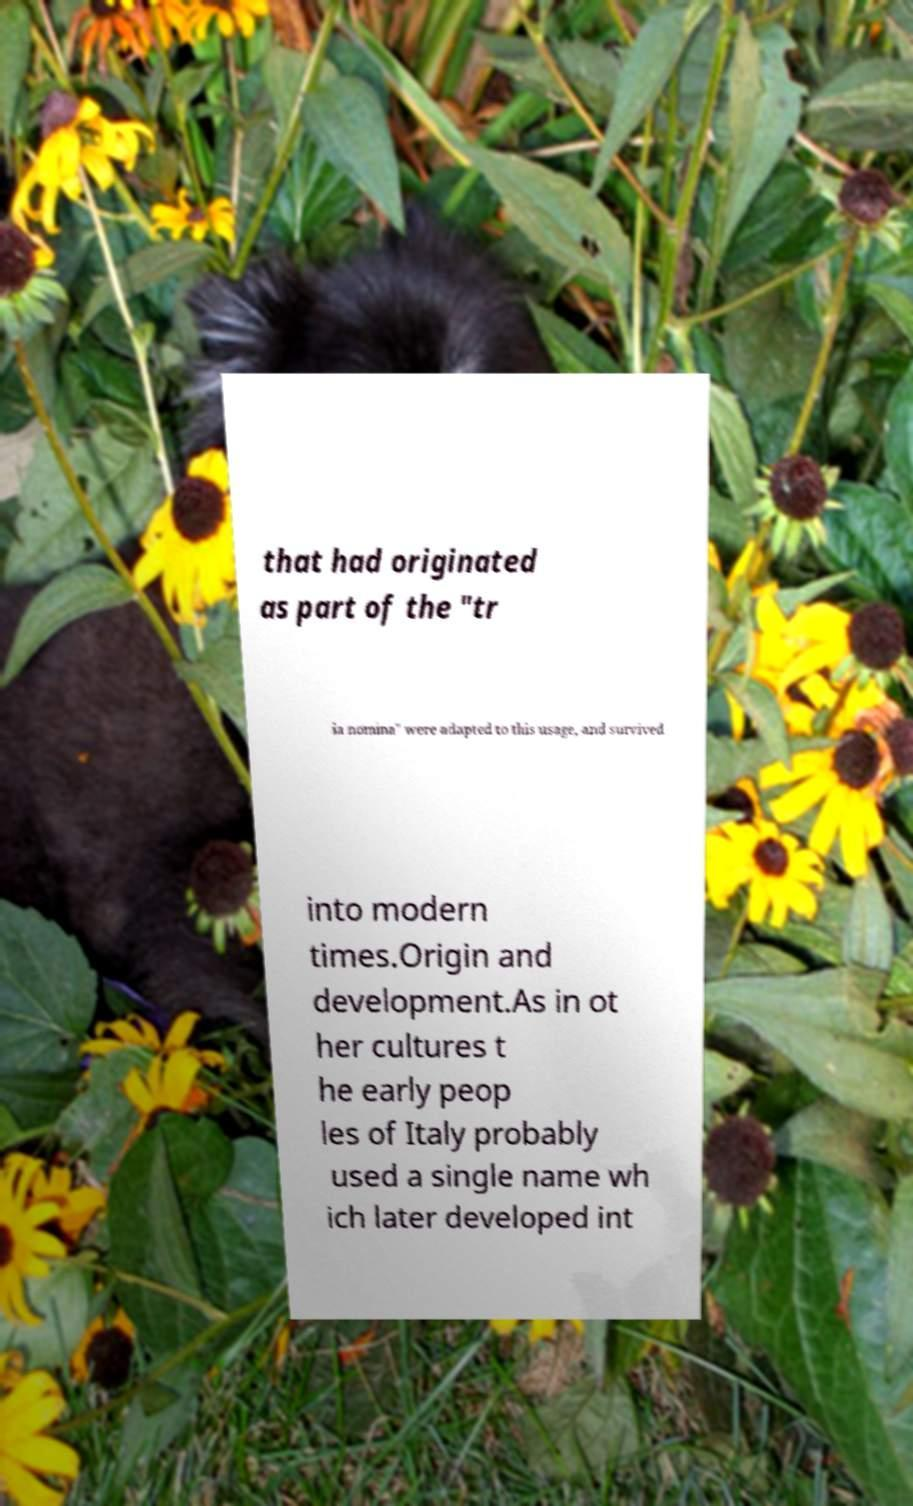Could you assist in decoding the text presented in this image and type it out clearly? that had originated as part of the "tr ia nomina" were adapted to this usage, and survived into modern times.Origin and development.As in ot her cultures t he early peop les of Italy probably used a single name wh ich later developed int 